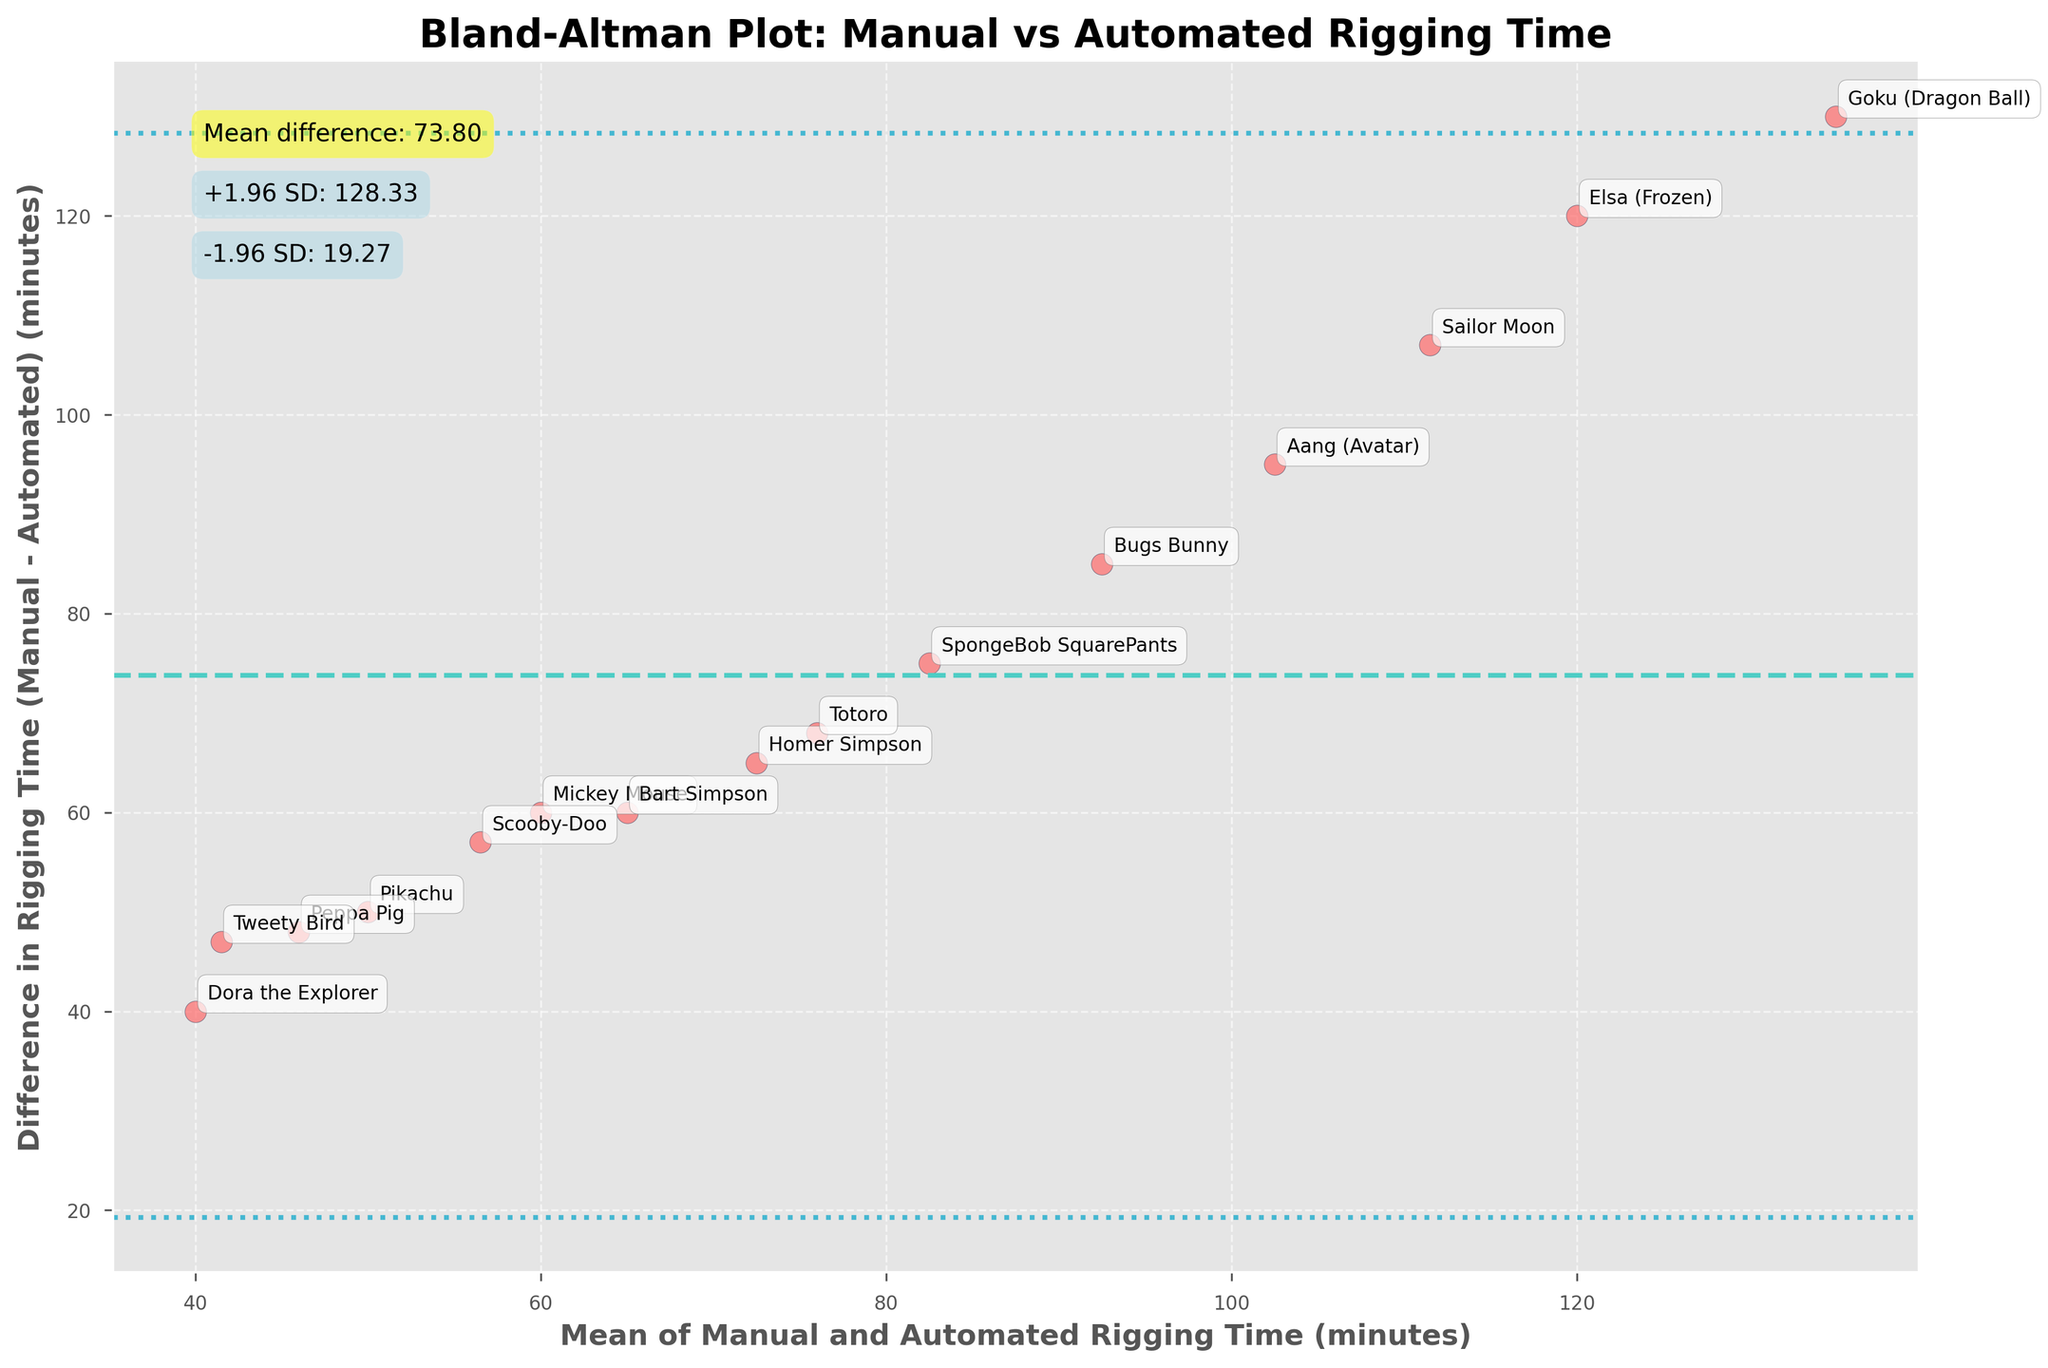What is the title of the plot? The title of the plot is usually at the top and typically describes what the plot is about. In this case, it states the subject of the analysis, which is comparing manual versus automated rigging time for 2D character animation.
Answer: Bland-Altman Plot: Manual vs Automated Rigging Time How many characters are analyzed in the plot? Count the number of unique labels (character names) that are annotated around the points in the scatter plot. Each label represents an individual data point.
Answer: 15 What do the x-axis and y-axis represent? The labels on the axes indicate what data is being plotted. The x-axis represents the "Mean of Manual and Automated Rigging Time (minutes)," and the y-axis represents the "Difference in Rigging Time (Manual - Automated) (minutes)."
Answer: Mean rigging time and Difference in rigging time What is the mean difference in rigging time between manual and automated methods? The mean difference is annotated on the plot, usually in a box near the top of the figure. It is also the solid horizontal line in the plot.
Answer: -108.33 What are the upper and lower limits of agreement? The limits of agreement are typically annotated on the plot. They are represented by the dotted horizontal lines above and below the mean difference.
Answer: +1.96 SD: -70.14, -1.96 SD: -146.52 Which character has the largest difference in rigging time between the manual and automated methods? Look for the point furthest from the x-axis. Check the annotated label of the character corresponding to this point.
Answer: Goku (Dragon Ball) What is the average of the mean rigging time for Mickey Mouse and Peppa Pig? First, find the mean rigging times for both characters (Mickey Mouse and Peppa Pig). Then, calculate their average. The mean rigging time for Mickey Mouse is (90+30)/2 = 60, and for Peppa Pig is (70+22)/2 = 46. The average of these means is (60 + 46) / 2 = 53.
Answer: 53 Which two characters have the closest difference in rigging time? Identify two points closest to each other vertically on the y-axis. Check the annotated labels to determine which characters they represent.
Answer: Aang (Avatar) and Bugs Bunny Are there any data points outside the limits of agreement? Check if any data points are above the upper limit of agreement line or below the lower limit of agreement line.
Answer: No What is the range of the mean rigging time values? Determine the minimum and maximum values on the x-axis to find the range. The x-axis range can be observed directly. The lowest mean time is 40 (Dora the Explorer), and the highest is 135 (Goku).
Answer: 40 to 135 minutes 